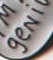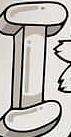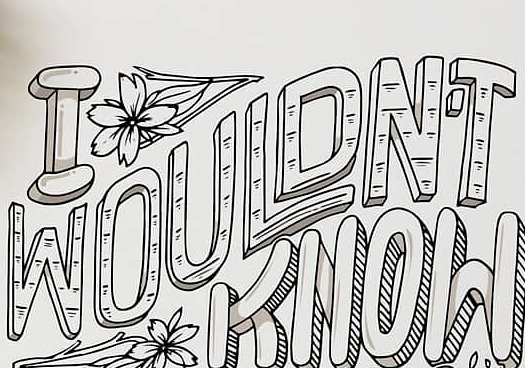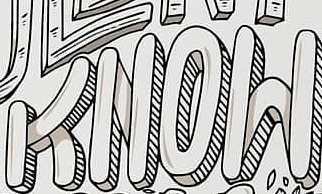Read the text content from these images in order, separated by a semicolon. geNi; I; WOULDN'T; KNOW 